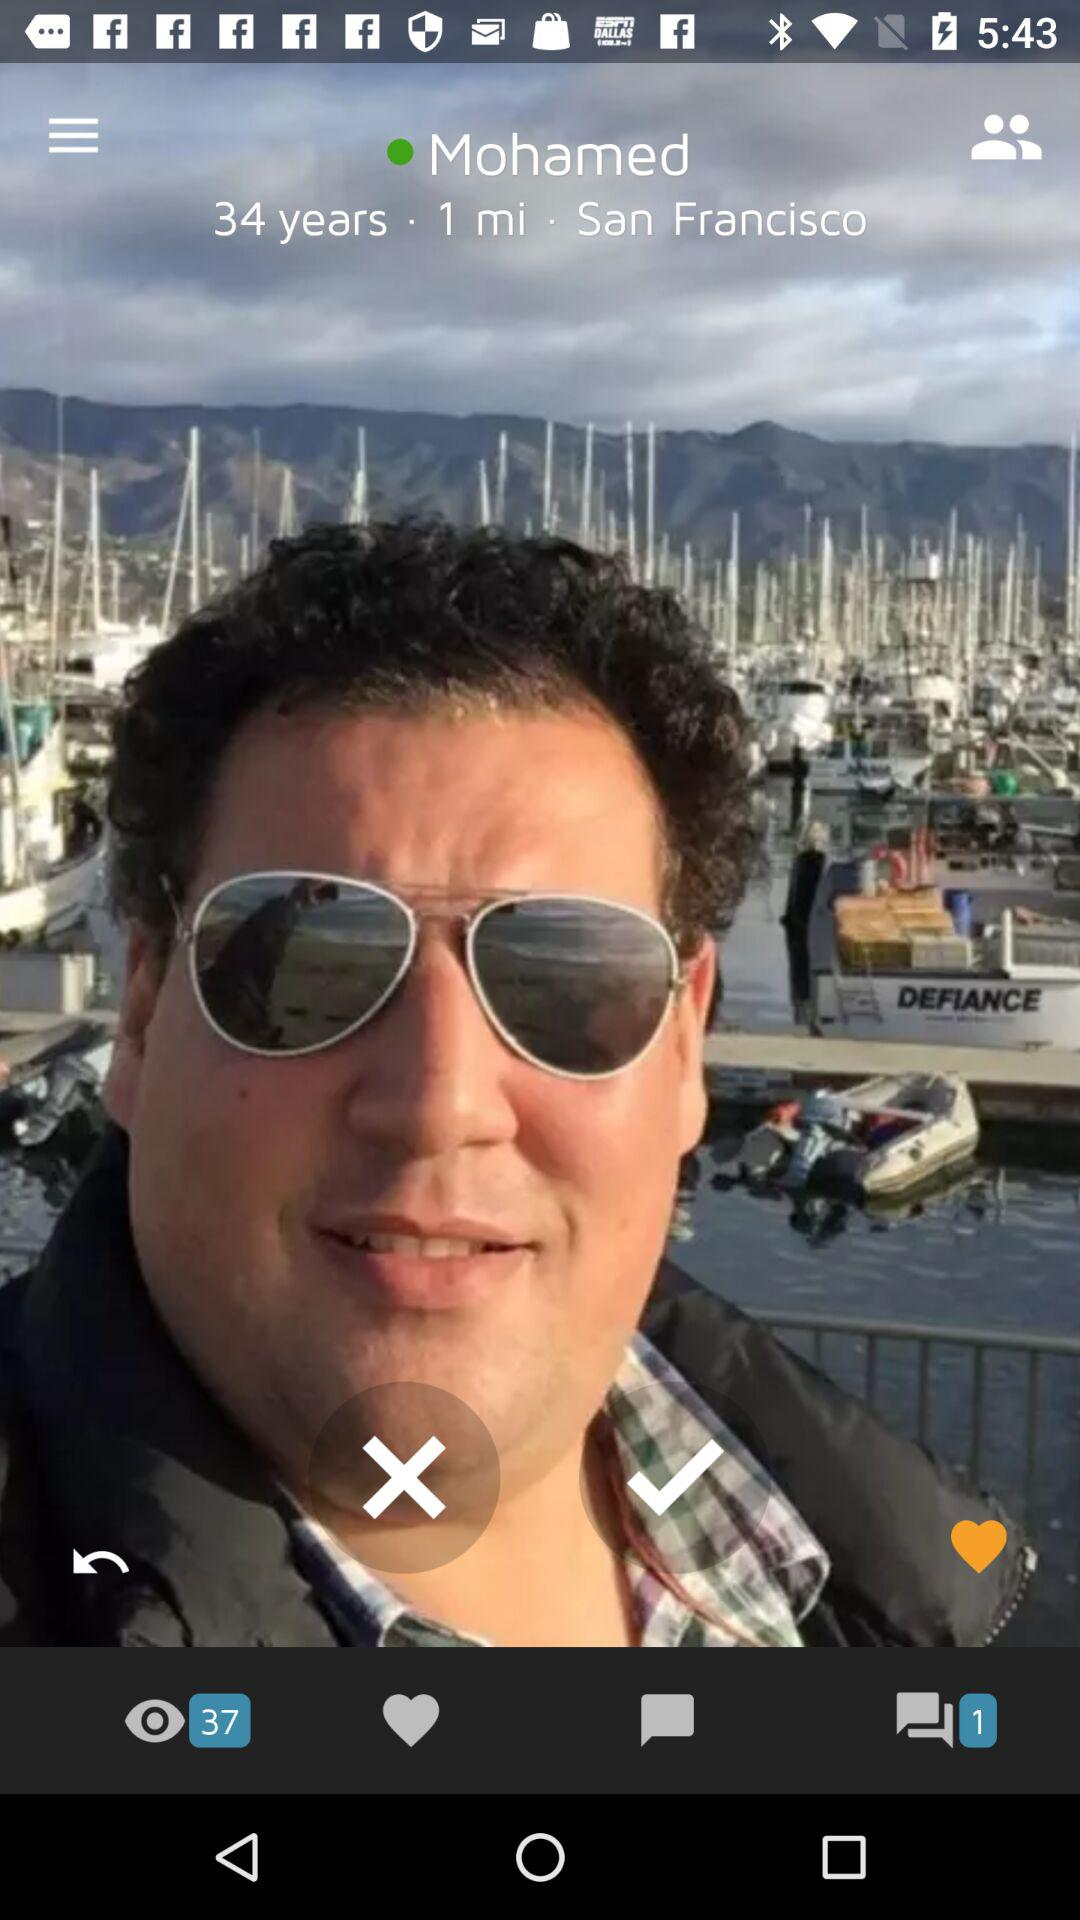How many unread messages are there? There is 1 unread message. 